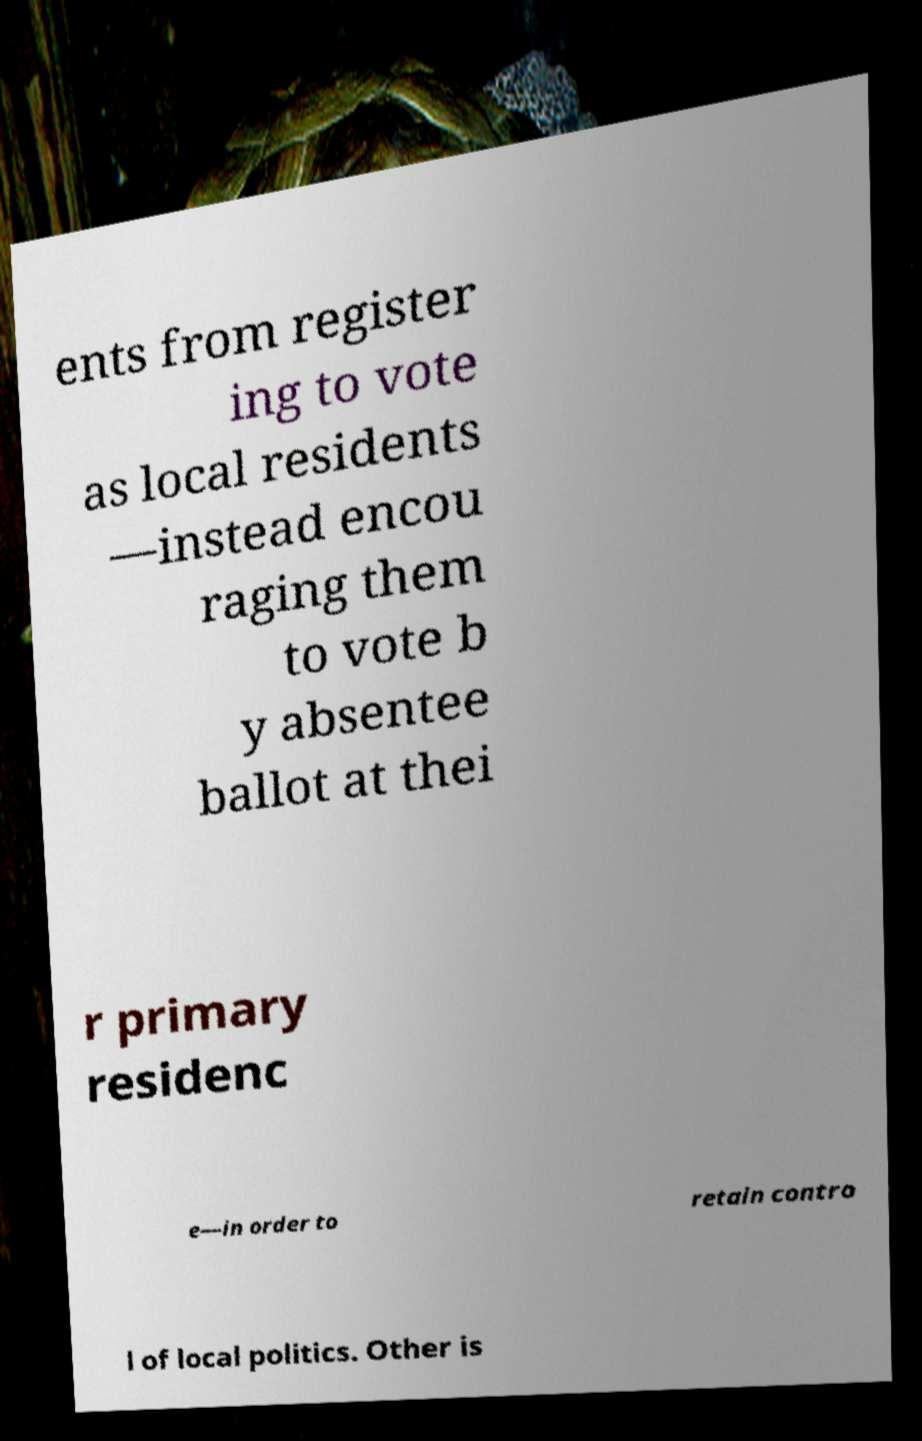Please read and relay the text visible in this image. What does it say? ents from register ing to vote as local residents —instead encou raging them to vote b y absentee ballot at thei r primary residenc e—in order to retain contro l of local politics. Other is 